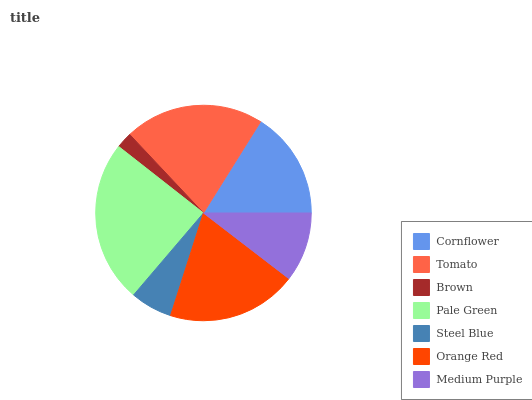Is Brown the minimum?
Answer yes or no. Yes. Is Pale Green the maximum?
Answer yes or no. Yes. Is Tomato the minimum?
Answer yes or no. No. Is Tomato the maximum?
Answer yes or no. No. Is Tomato greater than Cornflower?
Answer yes or no. Yes. Is Cornflower less than Tomato?
Answer yes or no. Yes. Is Cornflower greater than Tomato?
Answer yes or no. No. Is Tomato less than Cornflower?
Answer yes or no. No. Is Cornflower the high median?
Answer yes or no. Yes. Is Cornflower the low median?
Answer yes or no. Yes. Is Brown the high median?
Answer yes or no. No. Is Orange Red the low median?
Answer yes or no. No. 